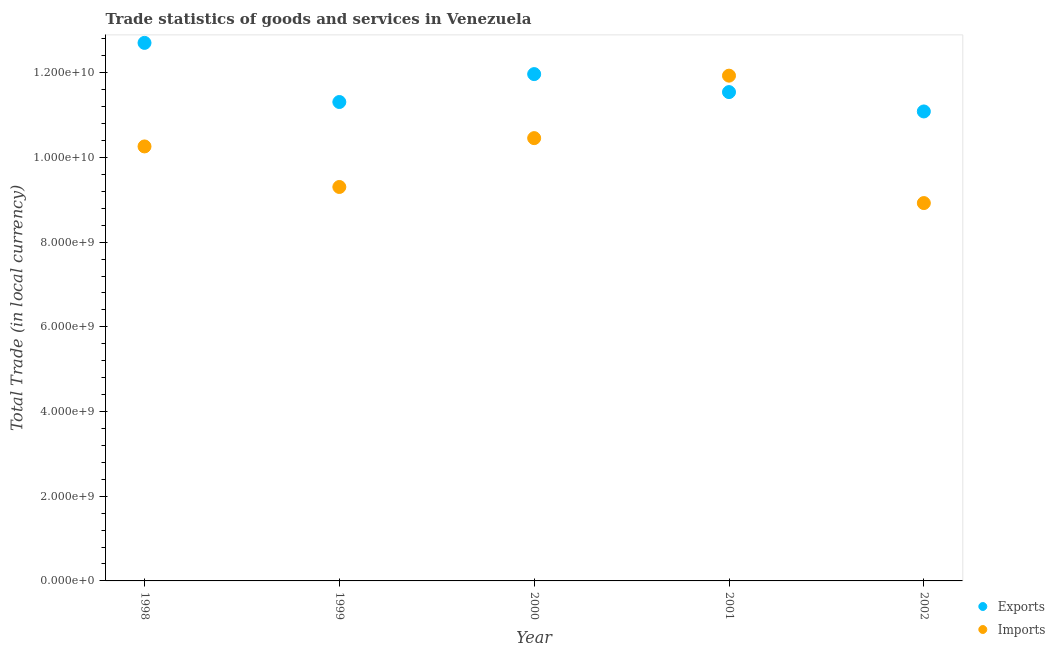What is the imports of goods and services in 2000?
Offer a terse response. 1.05e+1. Across all years, what is the maximum export of goods and services?
Give a very brief answer. 1.27e+1. Across all years, what is the minimum export of goods and services?
Keep it short and to the point. 1.11e+1. In which year was the export of goods and services maximum?
Make the answer very short. 1998. What is the total export of goods and services in the graph?
Ensure brevity in your answer.  5.86e+1. What is the difference between the export of goods and services in 1999 and that in 2002?
Provide a short and direct response. 2.23e+08. What is the difference between the export of goods and services in 2001 and the imports of goods and services in 2000?
Your answer should be compact. 1.09e+09. What is the average export of goods and services per year?
Your response must be concise. 1.17e+1. In the year 1999, what is the difference between the export of goods and services and imports of goods and services?
Your response must be concise. 2.01e+09. What is the ratio of the export of goods and services in 1999 to that in 2002?
Your response must be concise. 1.02. Is the imports of goods and services in 1998 less than that in 2000?
Ensure brevity in your answer.  Yes. Is the difference between the imports of goods and services in 2000 and 2001 greater than the difference between the export of goods and services in 2000 and 2001?
Keep it short and to the point. No. What is the difference between the highest and the second highest export of goods and services?
Ensure brevity in your answer.  7.37e+08. What is the difference between the highest and the lowest export of goods and services?
Give a very brief answer. 1.62e+09. Is the sum of the imports of goods and services in 1999 and 2000 greater than the maximum export of goods and services across all years?
Your answer should be very brief. Yes. Does the imports of goods and services monotonically increase over the years?
Provide a succinct answer. No. How many dotlines are there?
Offer a very short reply. 2. Are the values on the major ticks of Y-axis written in scientific E-notation?
Offer a very short reply. Yes. Where does the legend appear in the graph?
Keep it short and to the point. Bottom right. What is the title of the graph?
Your response must be concise. Trade statistics of goods and services in Venezuela. What is the label or title of the X-axis?
Your answer should be compact. Year. What is the label or title of the Y-axis?
Your answer should be compact. Total Trade (in local currency). What is the Total Trade (in local currency) in Exports in 1998?
Ensure brevity in your answer.  1.27e+1. What is the Total Trade (in local currency) in Imports in 1998?
Provide a succinct answer. 1.03e+1. What is the Total Trade (in local currency) in Exports in 1999?
Keep it short and to the point. 1.13e+1. What is the Total Trade (in local currency) in Imports in 1999?
Your answer should be compact. 9.30e+09. What is the Total Trade (in local currency) in Exports in 2000?
Keep it short and to the point. 1.20e+1. What is the Total Trade (in local currency) of Imports in 2000?
Ensure brevity in your answer.  1.05e+1. What is the Total Trade (in local currency) of Exports in 2001?
Keep it short and to the point. 1.15e+1. What is the Total Trade (in local currency) of Imports in 2001?
Your answer should be compact. 1.19e+1. What is the Total Trade (in local currency) of Exports in 2002?
Your answer should be very brief. 1.11e+1. What is the Total Trade (in local currency) in Imports in 2002?
Your answer should be compact. 8.92e+09. Across all years, what is the maximum Total Trade (in local currency) of Exports?
Your response must be concise. 1.27e+1. Across all years, what is the maximum Total Trade (in local currency) of Imports?
Provide a short and direct response. 1.19e+1. Across all years, what is the minimum Total Trade (in local currency) in Exports?
Offer a very short reply. 1.11e+1. Across all years, what is the minimum Total Trade (in local currency) of Imports?
Offer a very short reply. 8.92e+09. What is the total Total Trade (in local currency) of Exports in the graph?
Provide a short and direct response. 5.86e+1. What is the total Total Trade (in local currency) of Imports in the graph?
Your response must be concise. 5.09e+1. What is the difference between the Total Trade (in local currency) of Exports in 1998 and that in 1999?
Ensure brevity in your answer.  1.40e+09. What is the difference between the Total Trade (in local currency) in Imports in 1998 and that in 1999?
Give a very brief answer. 9.57e+08. What is the difference between the Total Trade (in local currency) in Exports in 1998 and that in 2000?
Give a very brief answer. 7.37e+08. What is the difference between the Total Trade (in local currency) in Imports in 1998 and that in 2000?
Offer a terse response. -1.96e+08. What is the difference between the Total Trade (in local currency) in Exports in 1998 and that in 2001?
Offer a very short reply. 1.16e+09. What is the difference between the Total Trade (in local currency) in Imports in 1998 and that in 2001?
Your answer should be compact. -1.67e+09. What is the difference between the Total Trade (in local currency) in Exports in 1998 and that in 2002?
Ensure brevity in your answer.  1.62e+09. What is the difference between the Total Trade (in local currency) of Imports in 1998 and that in 2002?
Your answer should be very brief. 1.34e+09. What is the difference between the Total Trade (in local currency) in Exports in 1999 and that in 2000?
Ensure brevity in your answer.  -6.59e+08. What is the difference between the Total Trade (in local currency) in Imports in 1999 and that in 2000?
Your response must be concise. -1.15e+09. What is the difference between the Total Trade (in local currency) of Exports in 1999 and that in 2001?
Keep it short and to the point. -2.34e+08. What is the difference between the Total Trade (in local currency) of Imports in 1999 and that in 2001?
Your response must be concise. -2.63e+09. What is the difference between the Total Trade (in local currency) in Exports in 1999 and that in 2002?
Offer a terse response. 2.23e+08. What is the difference between the Total Trade (in local currency) in Imports in 1999 and that in 2002?
Offer a terse response. 3.80e+08. What is the difference between the Total Trade (in local currency) in Exports in 2000 and that in 2001?
Provide a short and direct response. 4.25e+08. What is the difference between the Total Trade (in local currency) in Imports in 2000 and that in 2001?
Keep it short and to the point. -1.48e+09. What is the difference between the Total Trade (in local currency) in Exports in 2000 and that in 2002?
Keep it short and to the point. 8.82e+08. What is the difference between the Total Trade (in local currency) of Imports in 2000 and that in 2002?
Keep it short and to the point. 1.53e+09. What is the difference between the Total Trade (in local currency) in Exports in 2001 and that in 2002?
Ensure brevity in your answer.  4.57e+08. What is the difference between the Total Trade (in local currency) of Imports in 2001 and that in 2002?
Provide a short and direct response. 3.01e+09. What is the difference between the Total Trade (in local currency) of Exports in 1998 and the Total Trade (in local currency) of Imports in 1999?
Your answer should be very brief. 3.40e+09. What is the difference between the Total Trade (in local currency) in Exports in 1998 and the Total Trade (in local currency) in Imports in 2000?
Keep it short and to the point. 2.25e+09. What is the difference between the Total Trade (in local currency) of Exports in 1998 and the Total Trade (in local currency) of Imports in 2001?
Provide a succinct answer. 7.74e+08. What is the difference between the Total Trade (in local currency) in Exports in 1998 and the Total Trade (in local currency) in Imports in 2002?
Ensure brevity in your answer.  3.78e+09. What is the difference between the Total Trade (in local currency) in Exports in 1999 and the Total Trade (in local currency) in Imports in 2000?
Provide a succinct answer. 8.53e+08. What is the difference between the Total Trade (in local currency) of Exports in 1999 and the Total Trade (in local currency) of Imports in 2001?
Offer a very short reply. -6.22e+08. What is the difference between the Total Trade (in local currency) of Exports in 1999 and the Total Trade (in local currency) of Imports in 2002?
Keep it short and to the point. 2.39e+09. What is the difference between the Total Trade (in local currency) in Exports in 2000 and the Total Trade (in local currency) in Imports in 2001?
Offer a terse response. 3.69e+07. What is the difference between the Total Trade (in local currency) in Exports in 2000 and the Total Trade (in local currency) in Imports in 2002?
Offer a very short reply. 3.05e+09. What is the difference between the Total Trade (in local currency) in Exports in 2001 and the Total Trade (in local currency) in Imports in 2002?
Your answer should be very brief. 2.62e+09. What is the average Total Trade (in local currency) in Exports per year?
Your response must be concise. 1.17e+1. What is the average Total Trade (in local currency) of Imports per year?
Provide a succinct answer. 1.02e+1. In the year 1998, what is the difference between the Total Trade (in local currency) of Exports and Total Trade (in local currency) of Imports?
Provide a short and direct response. 2.45e+09. In the year 1999, what is the difference between the Total Trade (in local currency) of Exports and Total Trade (in local currency) of Imports?
Keep it short and to the point. 2.01e+09. In the year 2000, what is the difference between the Total Trade (in local currency) in Exports and Total Trade (in local currency) in Imports?
Ensure brevity in your answer.  1.51e+09. In the year 2001, what is the difference between the Total Trade (in local currency) in Exports and Total Trade (in local currency) in Imports?
Ensure brevity in your answer.  -3.88e+08. In the year 2002, what is the difference between the Total Trade (in local currency) of Exports and Total Trade (in local currency) of Imports?
Your response must be concise. 2.16e+09. What is the ratio of the Total Trade (in local currency) in Exports in 1998 to that in 1999?
Give a very brief answer. 1.12. What is the ratio of the Total Trade (in local currency) of Imports in 1998 to that in 1999?
Your answer should be very brief. 1.1. What is the ratio of the Total Trade (in local currency) of Exports in 1998 to that in 2000?
Offer a terse response. 1.06. What is the ratio of the Total Trade (in local currency) in Imports in 1998 to that in 2000?
Your answer should be compact. 0.98. What is the ratio of the Total Trade (in local currency) of Exports in 1998 to that in 2001?
Your response must be concise. 1.1. What is the ratio of the Total Trade (in local currency) of Imports in 1998 to that in 2001?
Make the answer very short. 0.86. What is the ratio of the Total Trade (in local currency) of Exports in 1998 to that in 2002?
Make the answer very short. 1.15. What is the ratio of the Total Trade (in local currency) in Imports in 1998 to that in 2002?
Offer a very short reply. 1.15. What is the ratio of the Total Trade (in local currency) in Exports in 1999 to that in 2000?
Provide a short and direct response. 0.94. What is the ratio of the Total Trade (in local currency) of Imports in 1999 to that in 2000?
Make the answer very short. 0.89. What is the ratio of the Total Trade (in local currency) of Exports in 1999 to that in 2001?
Provide a short and direct response. 0.98. What is the ratio of the Total Trade (in local currency) in Imports in 1999 to that in 2001?
Ensure brevity in your answer.  0.78. What is the ratio of the Total Trade (in local currency) in Exports in 1999 to that in 2002?
Your answer should be very brief. 1.02. What is the ratio of the Total Trade (in local currency) of Imports in 1999 to that in 2002?
Provide a succinct answer. 1.04. What is the ratio of the Total Trade (in local currency) of Exports in 2000 to that in 2001?
Your answer should be compact. 1.04. What is the ratio of the Total Trade (in local currency) in Imports in 2000 to that in 2001?
Keep it short and to the point. 0.88. What is the ratio of the Total Trade (in local currency) in Exports in 2000 to that in 2002?
Offer a terse response. 1.08. What is the ratio of the Total Trade (in local currency) in Imports in 2000 to that in 2002?
Provide a succinct answer. 1.17. What is the ratio of the Total Trade (in local currency) in Exports in 2001 to that in 2002?
Make the answer very short. 1.04. What is the ratio of the Total Trade (in local currency) of Imports in 2001 to that in 2002?
Give a very brief answer. 1.34. What is the difference between the highest and the second highest Total Trade (in local currency) of Exports?
Provide a short and direct response. 7.37e+08. What is the difference between the highest and the second highest Total Trade (in local currency) in Imports?
Your answer should be very brief. 1.48e+09. What is the difference between the highest and the lowest Total Trade (in local currency) in Exports?
Ensure brevity in your answer.  1.62e+09. What is the difference between the highest and the lowest Total Trade (in local currency) in Imports?
Your answer should be very brief. 3.01e+09. 